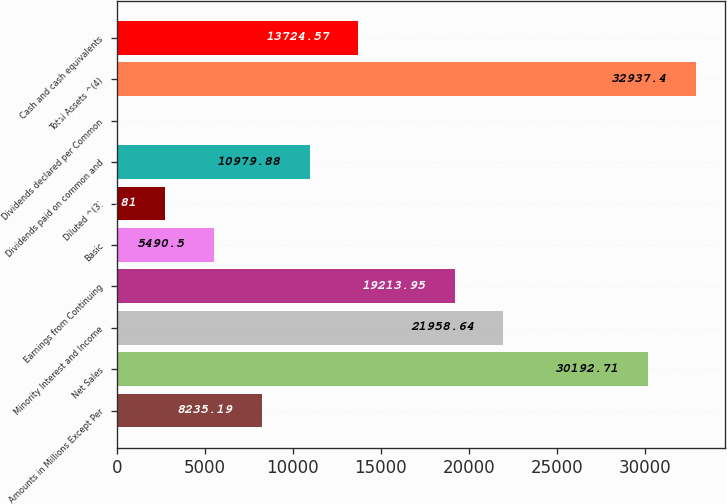<chart> <loc_0><loc_0><loc_500><loc_500><bar_chart><fcel>Amounts in Millions Except Per<fcel>Net Sales<fcel>Minority Interest and Income<fcel>Earnings from Continuing<fcel>Basic<fcel>Diluted ^(3)<fcel>Dividends paid on common and<fcel>Dividends declared per Common<fcel>Total Assets ^(4)<fcel>Cash and cash equivalents<nl><fcel>8235.19<fcel>30192.7<fcel>21958.6<fcel>19214<fcel>5490.5<fcel>2745.81<fcel>10979.9<fcel>1.12<fcel>32937.4<fcel>13724.6<nl></chart> 